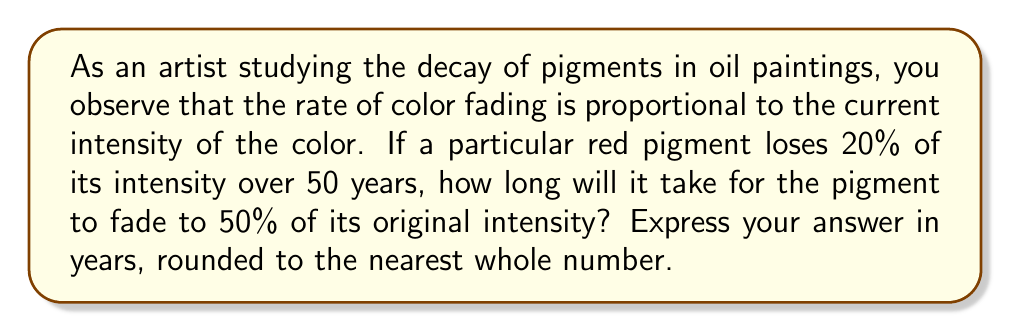Give your solution to this math problem. Let's approach this problem step-by-step using a first-order differential equation:

1) Let $I(t)$ be the intensity of the pigment at time $t$ (in years), with $I_0$ being the initial intensity.

2) The rate of decay is proportional to the current intensity:

   $$\frac{dI}{dt} = -kI$$

   where $k$ is the decay constant.

3) The solution to this differential equation is:

   $$I(t) = I_0 e^{-kt}$$

4) We're told that after 50 years, the intensity is 80% of the original. Let's use this to find $k$:

   $$0.8I_0 = I_0 e^{-k(50)}$$
   $$0.8 = e^{-50k}$$
   $$\ln(0.8) = -50k$$
   $$k = -\frac{\ln(0.8)}{50} \approx 0.00446$$

5) Now, we want to find $t$ when $I(t) = 0.5I_0$:

   $$0.5 = e^{-0.00446t}$$
   $$\ln(0.5) = -0.00446t$$
   $$t = -\frac{\ln(0.5)}{0.00446} \approx 155.4$$

6) Rounding to the nearest whole number, we get 155 years.
Answer: 155 years 